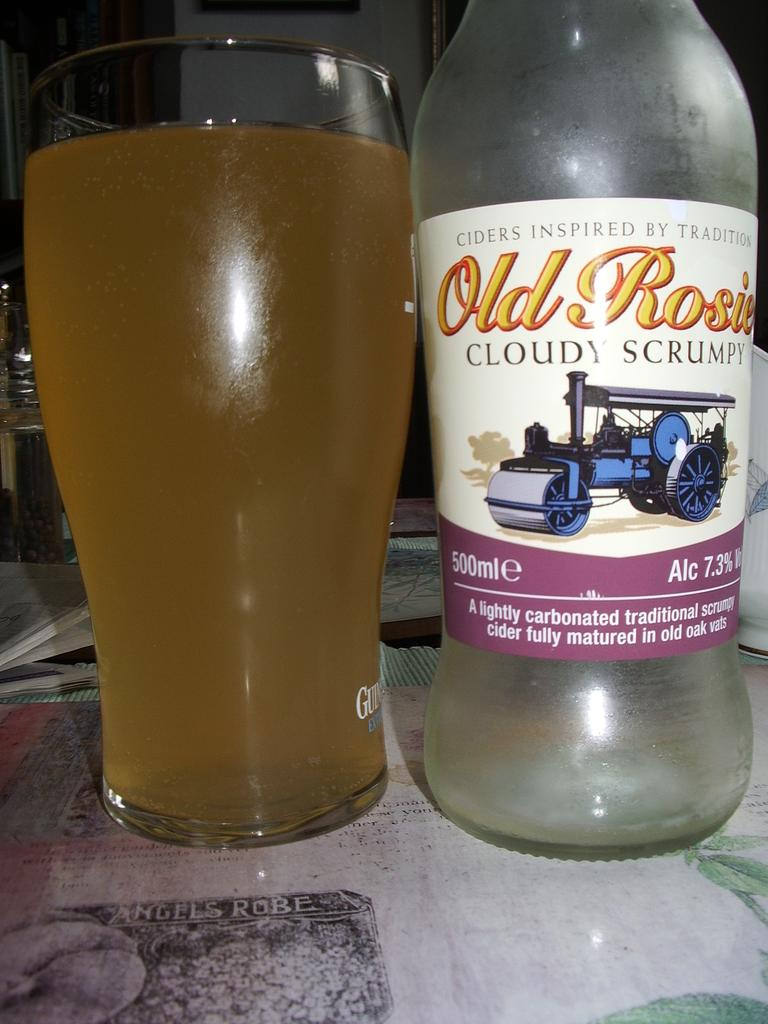<image>
Describe the image concisely. A bottle of Old Rosie cider next to a full glass. 